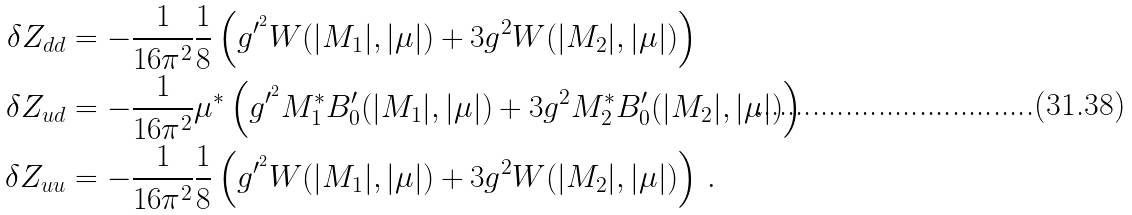Convert formula to latex. <formula><loc_0><loc_0><loc_500><loc_500>\delta Z _ { d d } & = - \frac { 1 } { 1 6 \pi ^ { 2 } } \frac { 1 } { 8 } \left ( g ^ { \prime ^ { 2 } } W ( | M _ { 1 } | , | \mu | ) + 3 g ^ { 2 } W ( | M _ { 2 } | , | \mu | ) \right ) \\ \delta Z _ { u d } & = - \frac { 1 } { 1 6 \pi ^ { 2 } } \mu ^ { * } \left ( g ^ { \prime ^ { 2 } } M _ { 1 } ^ { * } B _ { 0 } ^ { \prime } ( | M _ { 1 } | , | \mu | ) + 3 g ^ { 2 } M _ { 2 } ^ { * } B _ { 0 } ^ { \prime } ( | M _ { 2 } | , | \mu | ) \right ) \\ \delta Z _ { u u } & = - \frac { 1 } { 1 6 \pi ^ { 2 } } \frac { 1 } { 8 } \left ( g ^ { \prime ^ { 2 } } W ( | M _ { 1 } | , | \mu | ) + 3 g ^ { 2 } W ( | M _ { 2 } | , | \mu | ) \right ) \, . \\</formula> 